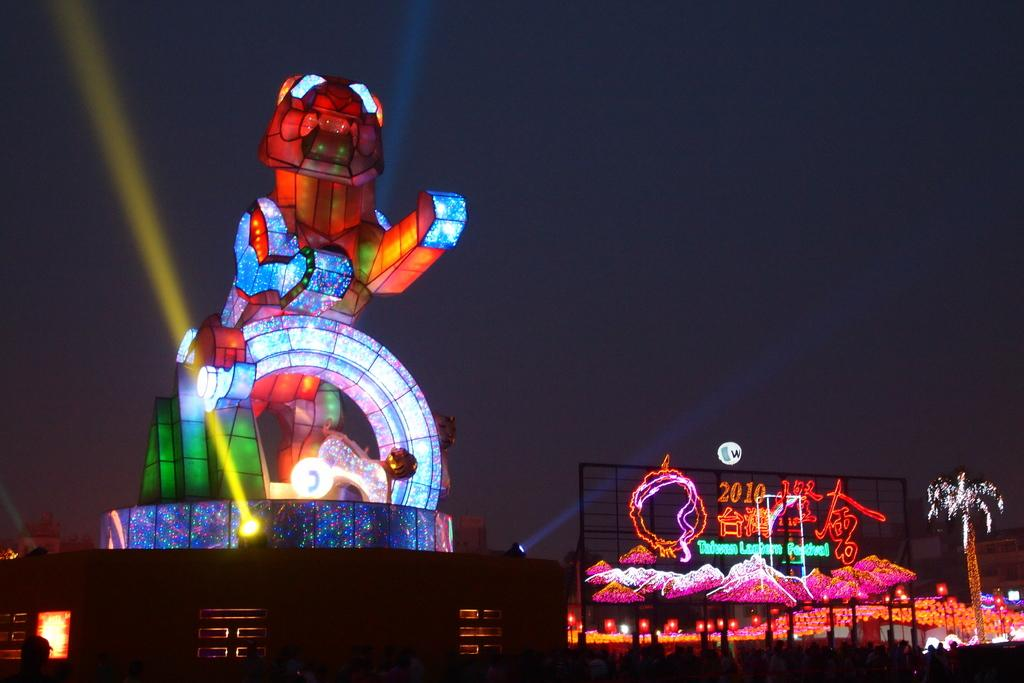What type of structures can be seen in the image? There are buildings and a structure visible in the image. What else is present in the image besides the buildings and structure? There are lights, a tree, people, and the sky visible in the image. Where are the people located in the image? The people are at the bottom of the image. What can be seen in the background of the image? The sky is visible in the background of the image. What type of maid is cleaning the ring in the image? There is no maid or ring present in the image. What division of labor is depicted in the image? The image does not depict any division of labor; it shows buildings, lights, a tree, a structure, people, and the sky. 